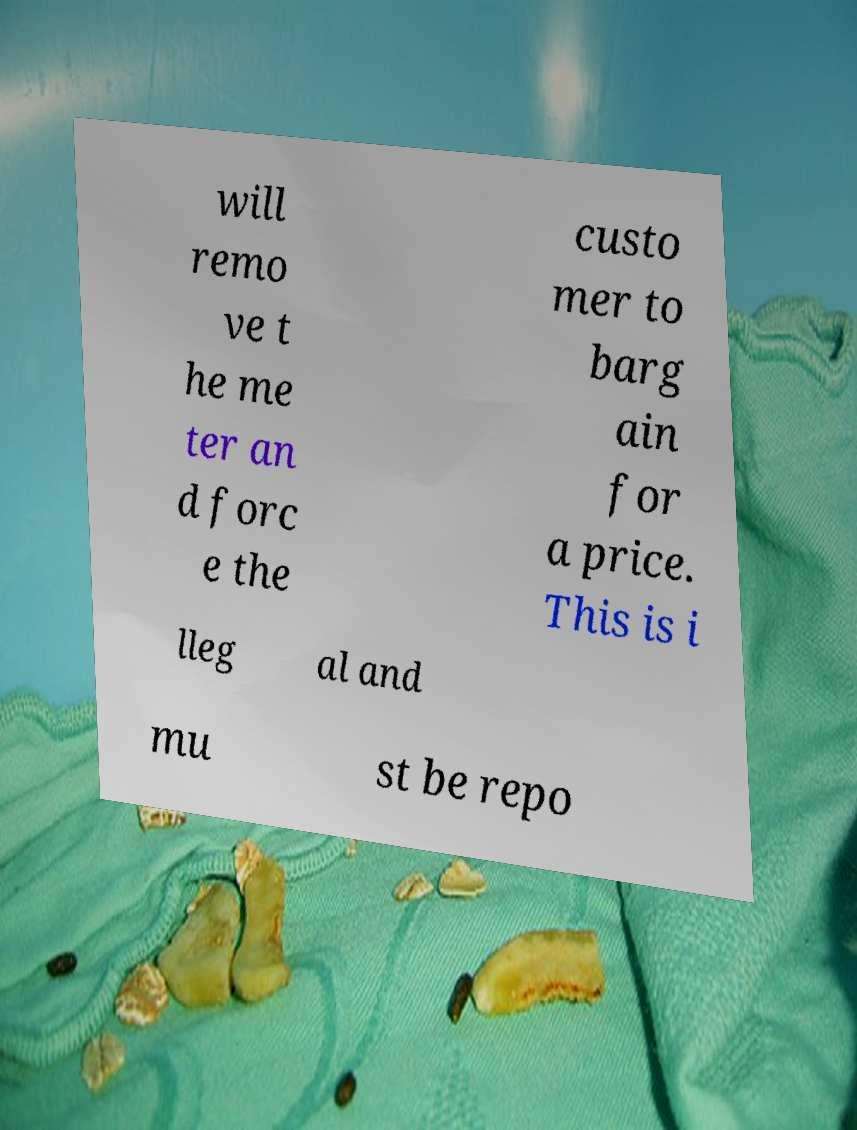What messages or text are displayed in this image? I need them in a readable, typed format. will remo ve t he me ter an d forc e the custo mer to barg ain for a price. This is i lleg al and mu st be repo 